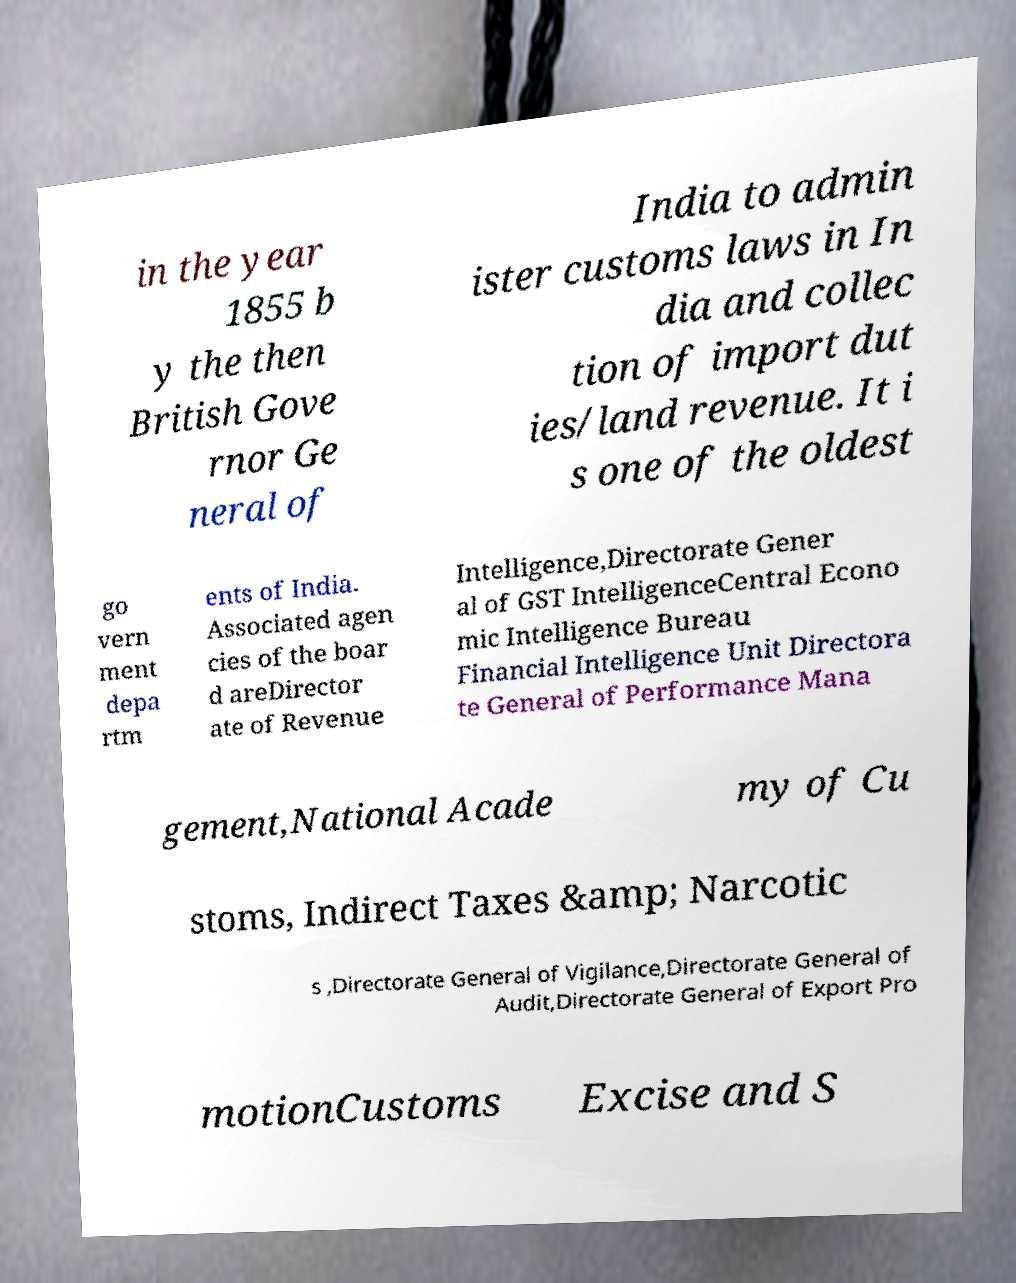For documentation purposes, I need the text within this image transcribed. Could you provide that? in the year 1855 b y the then British Gove rnor Ge neral of India to admin ister customs laws in In dia and collec tion of import dut ies/land revenue. It i s one of the oldest go vern ment depa rtm ents of India. Associated agen cies of the boar d areDirector ate of Revenue Intelligence,Directorate Gener al of GST IntelligenceCentral Econo mic Intelligence Bureau Financial Intelligence Unit Directora te General of Performance Mana gement,National Acade my of Cu stoms, Indirect Taxes &amp; Narcotic s ,Directorate General of Vigilance,Directorate General of Audit,Directorate General of Export Pro motionCustoms Excise and S 